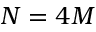Convert formula to latex. <formula><loc_0><loc_0><loc_500><loc_500>N = 4 M</formula> 